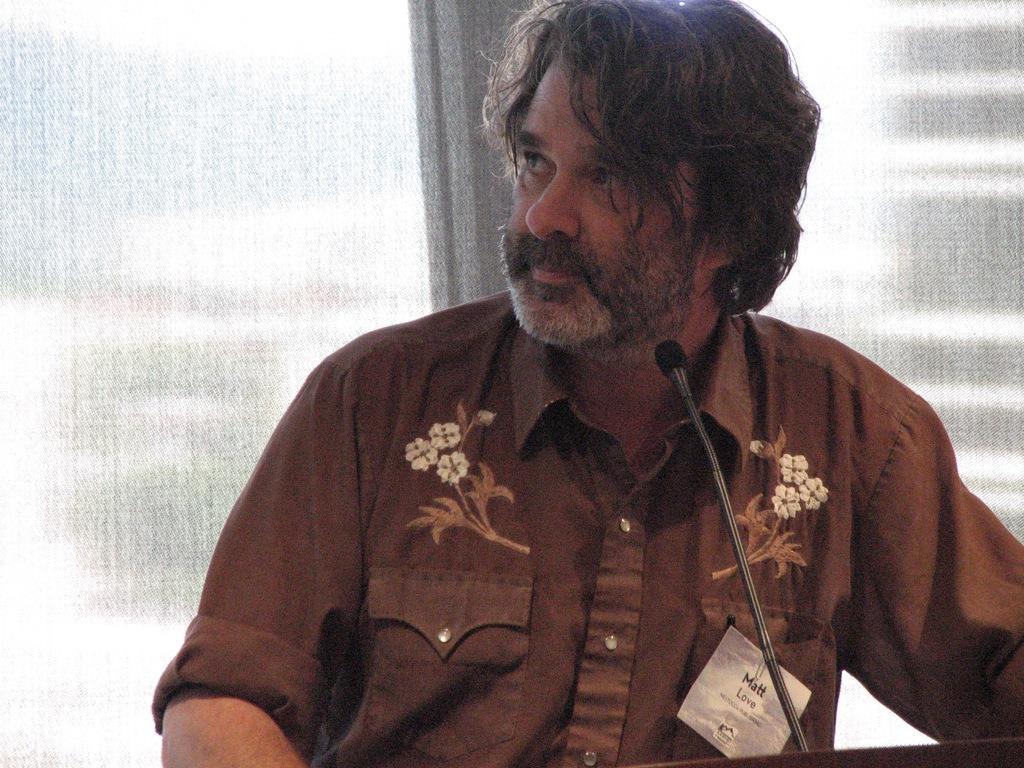Describe this image in one or two sentences. In this picture we can see a man in the shirt and in front of the man there is a microphone with stand. Behind the man there is an object. 